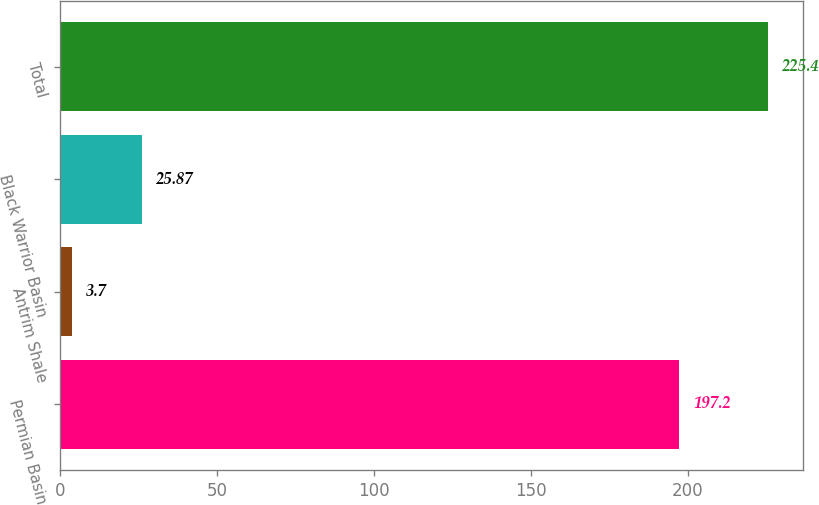Convert chart to OTSL. <chart><loc_0><loc_0><loc_500><loc_500><bar_chart><fcel>Permian Basin<fcel>Antrim Shale<fcel>Black Warrior Basin<fcel>Total<nl><fcel>197.2<fcel>3.7<fcel>25.87<fcel>225.4<nl></chart> 